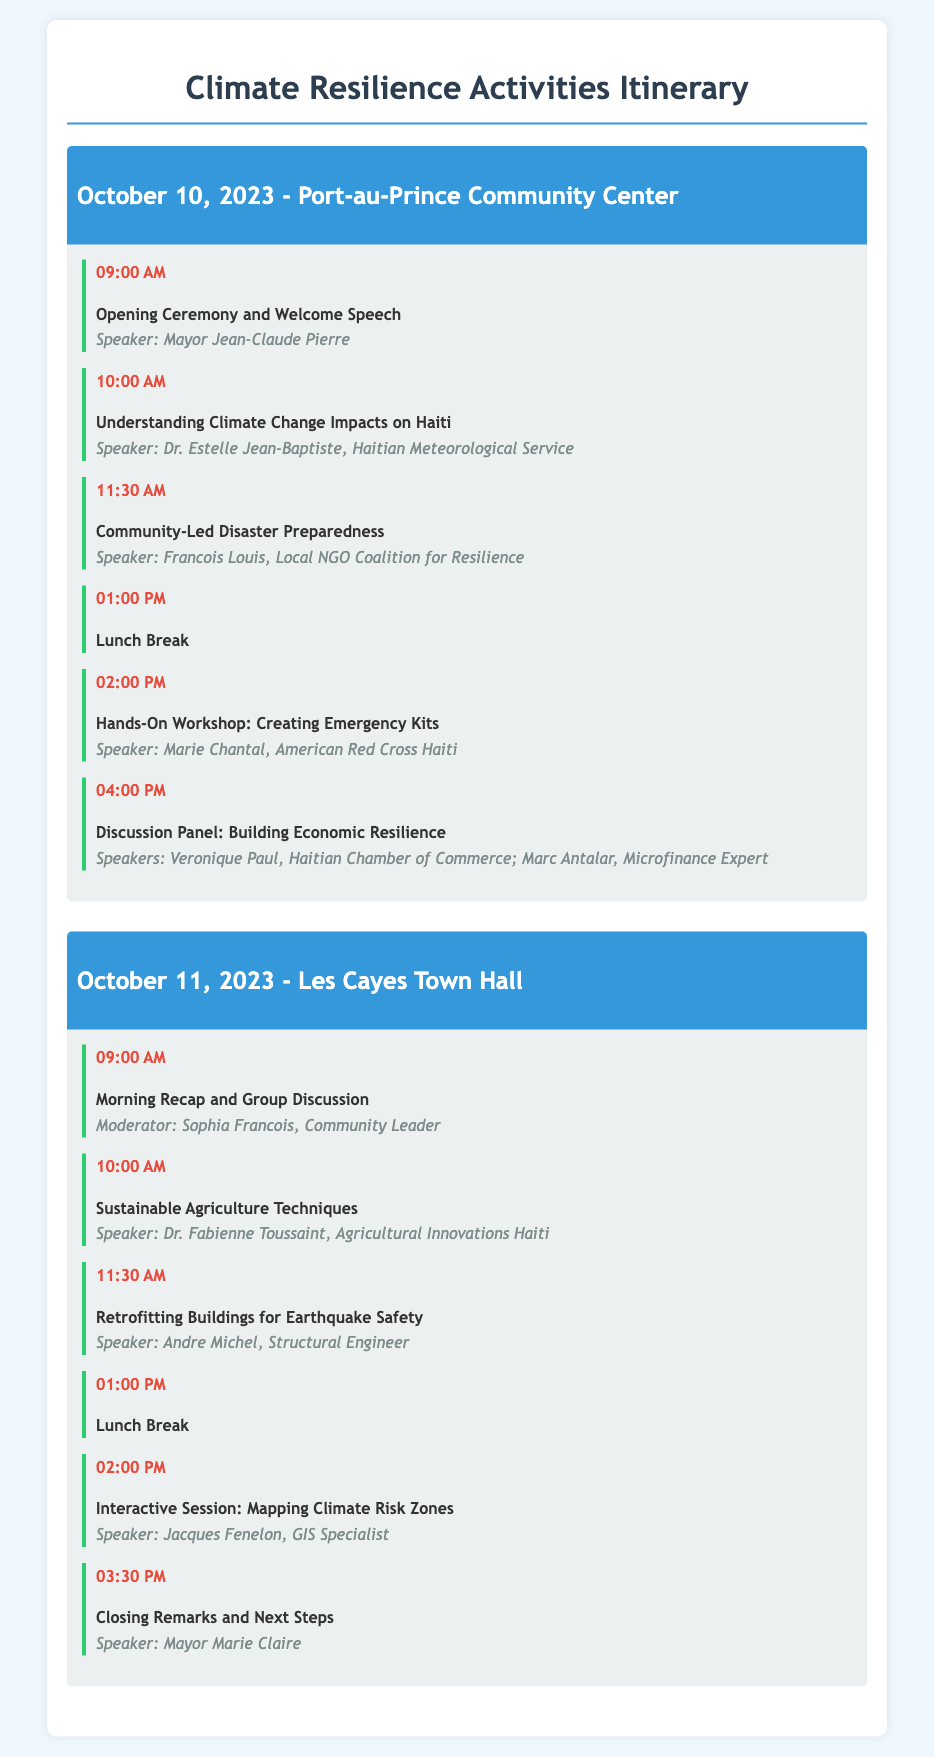What is the date of the first event? The date of the first event is explicitly stated in the document under the first date section.
Answer: October 10, 2023 Who is the speaker for the discussion panel on building economic resilience? The document lists multiple speakers for this panel in the last activity of the first day.
Answer: Veronique Paul, Marc Antalar What is the title of the workshop scheduled at 2:00 PM on October 10? The document provides specific details of each activity including their titles and times in the itinerary.
Answer: Hands-On Workshop: Creating Emergency Kits Where is the second day of events taking place? The location for the second day's events is mentioned in the header of the second date section.
Answer: Les Cayes Town Hall How long is the lunch break scheduled for both days? The document states the schedule for all activities, including the duration of lunch breaks.
Answer: 1 hour What topic is covered at 10:00 AM on October 11? This information can be found in the listing of activities which details titles and timings.
Answer: Sustainable Agriculture Techniques Who is moderating the morning recap on the second day? The document specifies the moderator for the morning recap in the second day's first activity.
Answer: Sophia Francois What is the time of the closing remarks on the second day? The document indicates the timing of this activity in the itinerary for the second day.
Answer: 03:30 PM What is the focus of the workshop on October 10 at 2:00 PM? This can be inferred from the title of the workshop provided in the activity list.
Answer: Creating Emergency Kits 